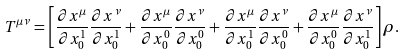Convert formula to latex. <formula><loc_0><loc_0><loc_500><loc_500>T ^ { \mu \nu } = \left [ \frac { \partial x ^ { \mu } } { \partial x _ { 0 } ^ { 1 } } \frac { \partial x ^ { \nu } } { \partial x _ { 0 } ^ { 1 } } + \frac { \partial x ^ { \mu } } { \partial x _ { 0 } ^ { 0 } } \frac { \partial x ^ { \nu } } { \partial x _ { 0 } ^ { 0 } } + \frac { \partial x ^ { \mu } } { \partial x _ { 0 } ^ { 1 } } \frac { \partial x ^ { \nu } } { \partial x _ { 0 } ^ { 0 } } + \frac { \partial x ^ { \mu } } { \partial x _ { 0 } ^ { 0 } } \frac { \partial x ^ { \nu } } { \partial x _ { 0 } ^ { 1 } } \right ] \rho .</formula> 